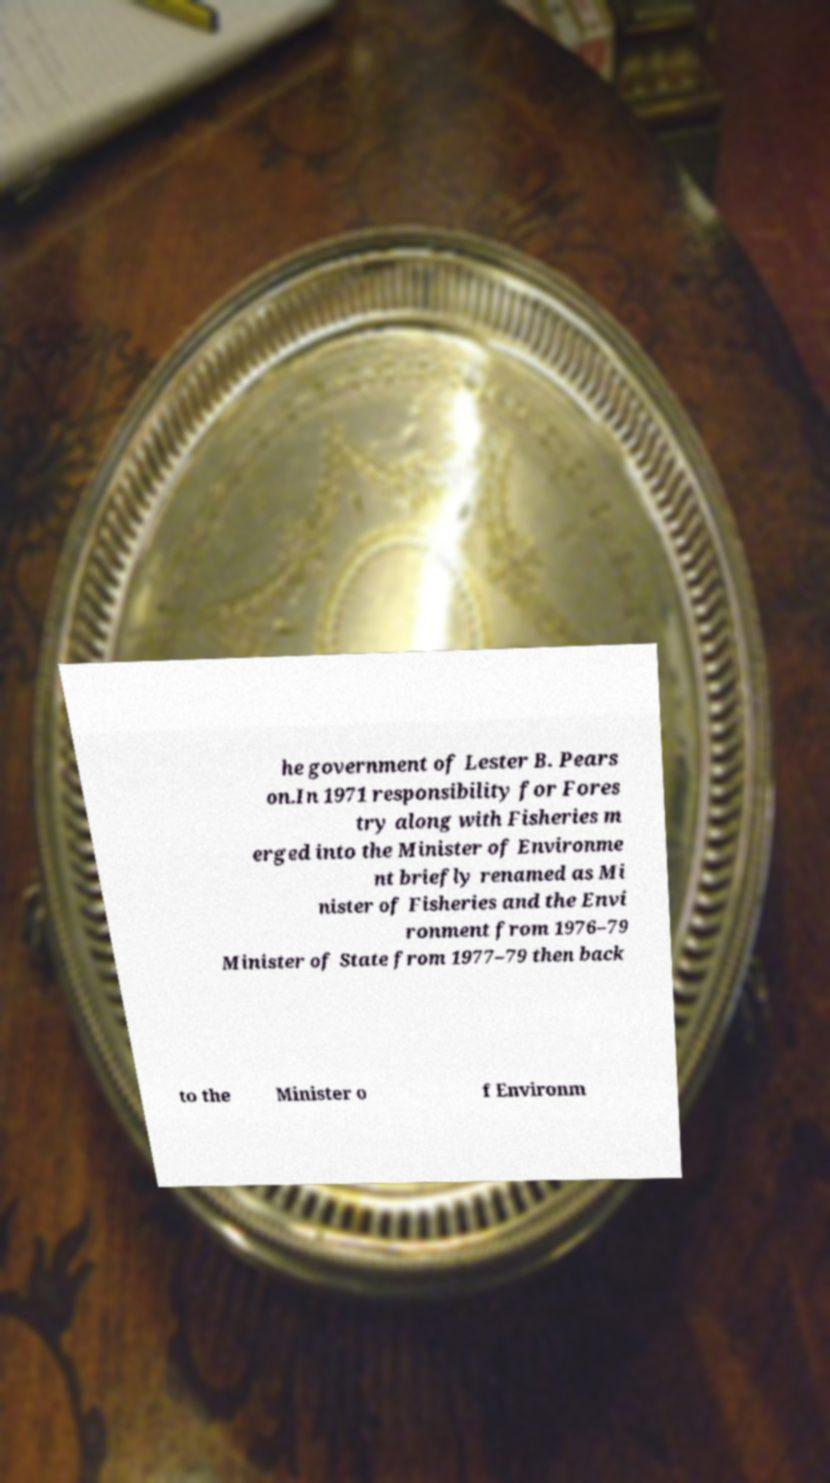Please identify and transcribe the text found in this image. he government of Lester B. Pears on.In 1971 responsibility for Fores try along with Fisheries m erged into the Minister of Environme nt briefly renamed as Mi nister of Fisheries and the Envi ronment from 1976–79 Minister of State from 1977–79 then back to the Minister o f Environm 